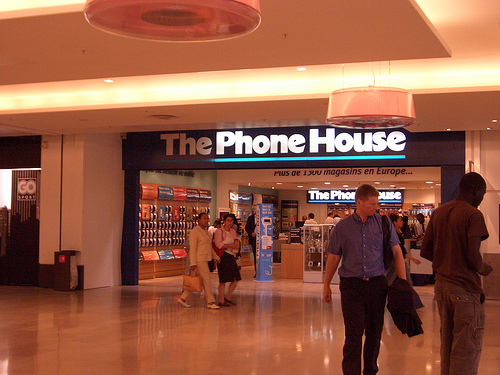<image>
Can you confirm if the bag is above the floor? Yes. The bag is positioned above the floor in the vertical space, higher up in the scene. 